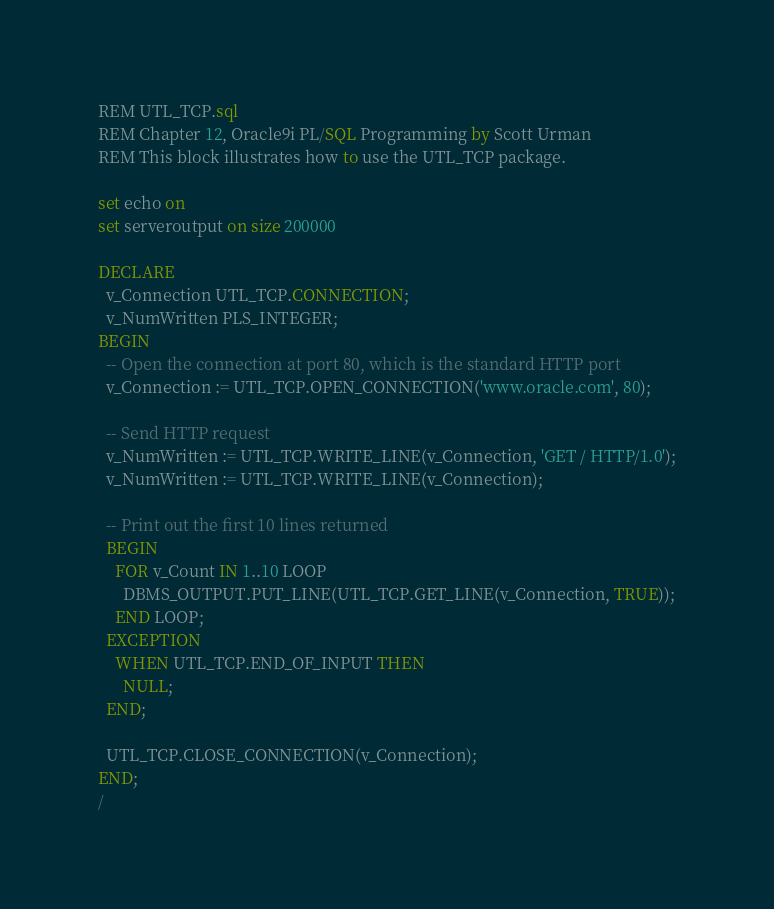<code> <loc_0><loc_0><loc_500><loc_500><_SQL_>REM UTL_TCP.sql
REM Chapter 12, Oracle9i PL/SQL Programming by Scott Urman
REM This block illustrates how to use the UTL_TCP package. 

set echo on
set serveroutput on size 200000

DECLARE
  v_Connection UTL_TCP.CONNECTION;
  v_NumWritten PLS_INTEGER;
BEGIN
  -- Open the connection at port 80, which is the standard HTTP port
  v_Connection := UTL_TCP.OPEN_CONNECTION('www.oracle.com', 80);

  -- Send HTTP request
  v_NumWritten := UTL_TCP.WRITE_LINE(v_Connection, 'GET / HTTP/1.0');
  v_NumWritten := UTL_TCP.WRITE_LINE(v_Connection);
  
  -- Print out the first 10 lines returned
  BEGIN
    FOR v_Count IN 1..10 LOOP
      DBMS_OUTPUT.PUT_LINE(UTL_TCP.GET_LINE(v_Connection, TRUE));
    END LOOP;
  EXCEPTION
    WHEN UTL_TCP.END_OF_INPUT THEN
      NULL;
  END;
  
  UTL_TCP.CLOSE_CONNECTION(v_Connection);
END;
/

</code> 